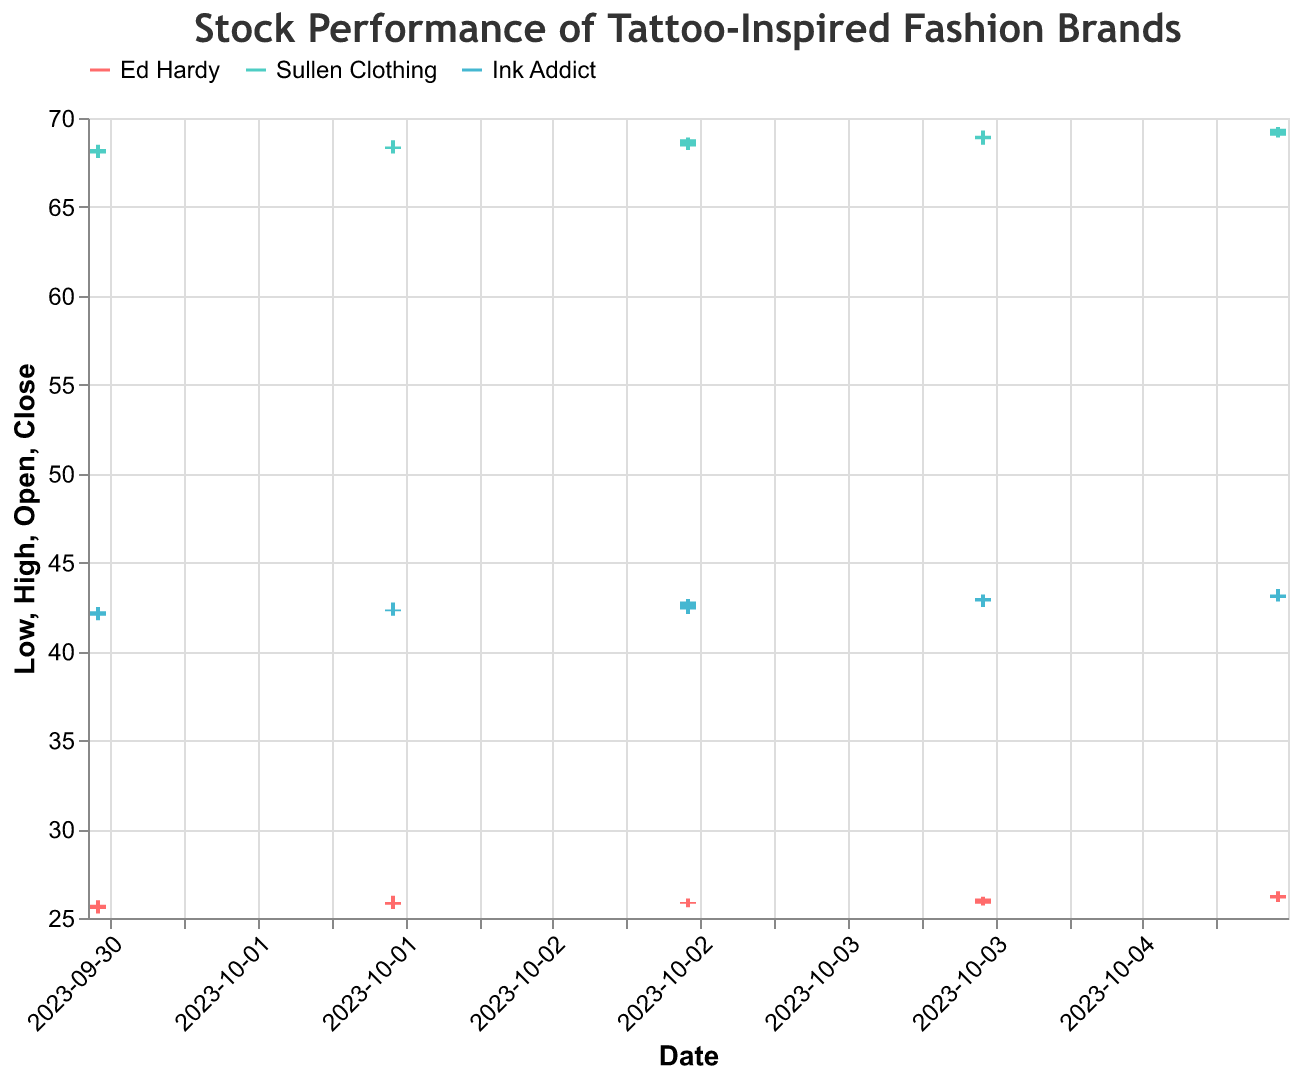What is the title of the figure? The title is prominently displayed at the top of the figure and reads "Stock Performance of Tattoo-Inspired Fashion Brands".
Answer: Stock Performance of Tattoo-Inspired Fashion Brands Which company had the highest closing price on 2023-10-03? Examine the candlestick components for 2023-10-03. For that date, Ink Addict had a closing price of 42.80, which is higher compared to Ed Hardy (25.80) and Sullen Clothing (68.80).
Answer: Ink Addict How does the volume of trades vary among the three companies on 2023-10-01? Check the volume values for each company on 2023-10-01. Ed Hardy has 105,000, Sullen Clothing has 95,000, and Ink Addict has 125,000. Thus Ink Addict has the highest trade volume, followed by Ed Hardy and then Sullen Clothing.
Answer: Ink Addict > Ed Hardy > Sullen Clothing What is the overall trend of Ed Hardy's stock prices within the period shown in the figure? Review Ed Hardy’s stock closing prices from October 1 to October 5. The prices gradually increase from 25.75 to 26.30, indicating an upward trend.
Answer: Upward trend Compare the closing prices of Sullen Clothing from 2023-10-01 to 2023-10-05. Has the stock experienced an overall increase, decrease, or remained stable? Check the closing prices of Sullen Clothing on each date: 68.25 (Oct 1), 68.40 (Oct 2), 68.80 (Oct 3), 69.00 (Oct 4), and 69.40 (Oct 5). The closing prices show a steady increase.
Answer: Increased What was the lowest price for Ink Addict on 2023-10-05, and how does it compare to the highest price for the same day? For 2023-10-05, the lowest price for Ink Addict was 42.80 and the highest price was 43.50. These values are provided in the candlestick representation.
Answer: 42.80 is the lowest, 43.50 is the highest Identify the date when Ed Hardy's stock had the highest trading volume. What was the volume? Examine the volumes listed for Ed Hardy. The highest volume is 120,000, which occurred on 2023-10-05.
Answer: 2023-10-05, 120,000 What was the range of Sullen Clothing’s stock prices on 2023-10-04? Review the high and low prices for Sullen Clothing on that date. The range is calculated as the high (69.30) minus the low (68.50), which is 0.80.
Answer: 0.80 Which company had the most consistent closing price between 2023-10-01 and 2023-10-05? To find this, look at the variability in the closing prices. Ink Addict's prices show less fluctuation, ranging from 42.25 to 43.20. Ed Hardy and Sullen Clothing had more variation in their prices.
Answer: Ink Addict 